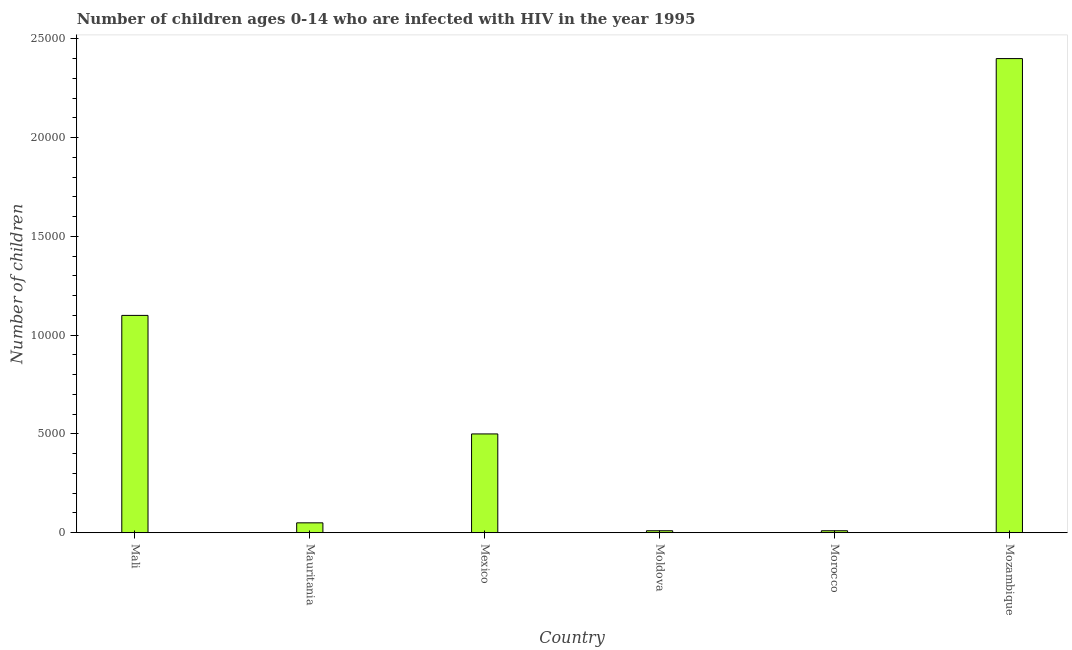Does the graph contain any zero values?
Give a very brief answer. No. Does the graph contain grids?
Your answer should be very brief. No. What is the title of the graph?
Provide a succinct answer. Number of children ages 0-14 who are infected with HIV in the year 1995. What is the label or title of the Y-axis?
Provide a short and direct response. Number of children. Across all countries, what is the maximum number of children living with hiv?
Offer a terse response. 2.40e+04. In which country was the number of children living with hiv maximum?
Provide a succinct answer. Mozambique. In which country was the number of children living with hiv minimum?
Provide a succinct answer. Moldova. What is the sum of the number of children living with hiv?
Your answer should be very brief. 4.07e+04. What is the difference between the number of children living with hiv in Moldova and Mozambique?
Your answer should be very brief. -2.39e+04. What is the average number of children living with hiv per country?
Your response must be concise. 6783. What is the median number of children living with hiv?
Provide a short and direct response. 2750. What is the difference between the highest and the second highest number of children living with hiv?
Give a very brief answer. 1.30e+04. What is the difference between the highest and the lowest number of children living with hiv?
Your answer should be compact. 2.39e+04. In how many countries, is the number of children living with hiv greater than the average number of children living with hiv taken over all countries?
Keep it short and to the point. 2. How many bars are there?
Your answer should be very brief. 6. Are all the bars in the graph horizontal?
Offer a very short reply. No. Are the values on the major ticks of Y-axis written in scientific E-notation?
Provide a short and direct response. No. What is the Number of children of Mali?
Provide a succinct answer. 1.10e+04. What is the Number of children of Mauritania?
Ensure brevity in your answer.  500. What is the Number of children of Mexico?
Ensure brevity in your answer.  5000. What is the Number of children in Morocco?
Keep it short and to the point. 100. What is the Number of children of Mozambique?
Keep it short and to the point. 2.40e+04. What is the difference between the Number of children in Mali and Mauritania?
Make the answer very short. 1.05e+04. What is the difference between the Number of children in Mali and Mexico?
Keep it short and to the point. 6000. What is the difference between the Number of children in Mali and Moldova?
Offer a terse response. 1.09e+04. What is the difference between the Number of children in Mali and Morocco?
Make the answer very short. 1.09e+04. What is the difference between the Number of children in Mali and Mozambique?
Your answer should be very brief. -1.30e+04. What is the difference between the Number of children in Mauritania and Mexico?
Give a very brief answer. -4500. What is the difference between the Number of children in Mauritania and Morocco?
Your response must be concise. 400. What is the difference between the Number of children in Mauritania and Mozambique?
Give a very brief answer. -2.35e+04. What is the difference between the Number of children in Mexico and Moldova?
Give a very brief answer. 4900. What is the difference between the Number of children in Mexico and Morocco?
Your answer should be very brief. 4900. What is the difference between the Number of children in Mexico and Mozambique?
Keep it short and to the point. -1.90e+04. What is the difference between the Number of children in Moldova and Mozambique?
Make the answer very short. -2.39e+04. What is the difference between the Number of children in Morocco and Mozambique?
Your response must be concise. -2.39e+04. What is the ratio of the Number of children in Mali to that in Mexico?
Keep it short and to the point. 2.2. What is the ratio of the Number of children in Mali to that in Moldova?
Your response must be concise. 110. What is the ratio of the Number of children in Mali to that in Morocco?
Make the answer very short. 110. What is the ratio of the Number of children in Mali to that in Mozambique?
Make the answer very short. 0.46. What is the ratio of the Number of children in Mauritania to that in Moldova?
Your answer should be compact. 5. What is the ratio of the Number of children in Mauritania to that in Morocco?
Provide a short and direct response. 5. What is the ratio of the Number of children in Mauritania to that in Mozambique?
Make the answer very short. 0.02. What is the ratio of the Number of children in Mexico to that in Moldova?
Ensure brevity in your answer.  50. What is the ratio of the Number of children in Mexico to that in Mozambique?
Your answer should be very brief. 0.21. What is the ratio of the Number of children in Moldova to that in Mozambique?
Offer a very short reply. 0. What is the ratio of the Number of children in Morocco to that in Mozambique?
Offer a very short reply. 0. 